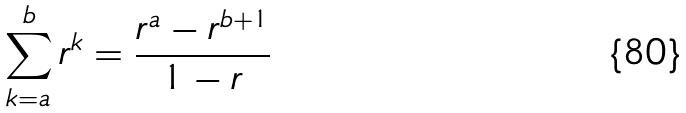<formula> <loc_0><loc_0><loc_500><loc_500>\sum _ { k = a } ^ { b } r ^ { k } = \frac { r ^ { a } - r ^ { b + 1 } } { 1 - r }</formula> 